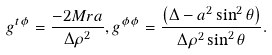Convert formula to latex. <formula><loc_0><loc_0><loc_500><loc_500>g ^ { t \phi } = \frac { - 2 M r a } { \Delta \rho ^ { 2 } } , g ^ { \phi \phi } = \frac { { \left ( { \Delta - a ^ { 2 } \sin ^ { 2 } \theta } \right ) } } { \Delta \rho ^ { 2 } \sin ^ { 2 } \theta } .</formula> 